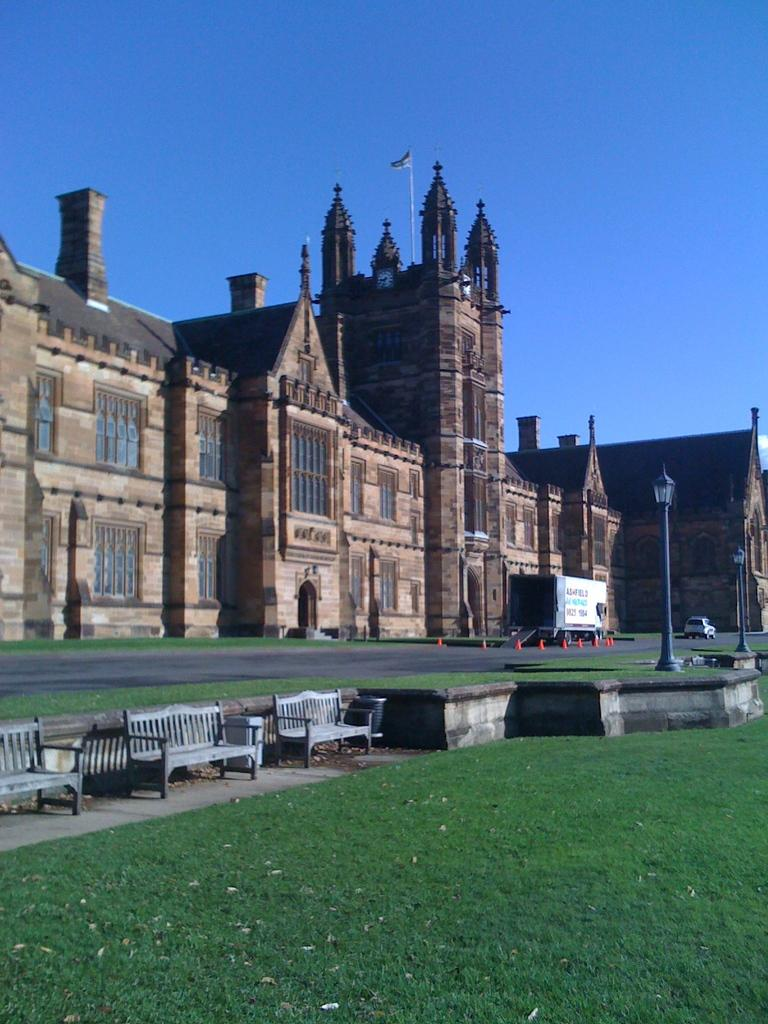What is located in the center of the image? There are buildings in the center of the image. What can be seen at the bottom of the image? There are branches and grass at the bottom of the image. What is on the right side of the image? There are poles on the right side of the image. What is visible in the background of the image? The sky is visible in the background of the image. What type of body is present in the image? There is no body present in the image; it features buildings, branches, grass, poles, and the sky. What religion is depicted in the image? There is no religious symbol or reference in the image. 